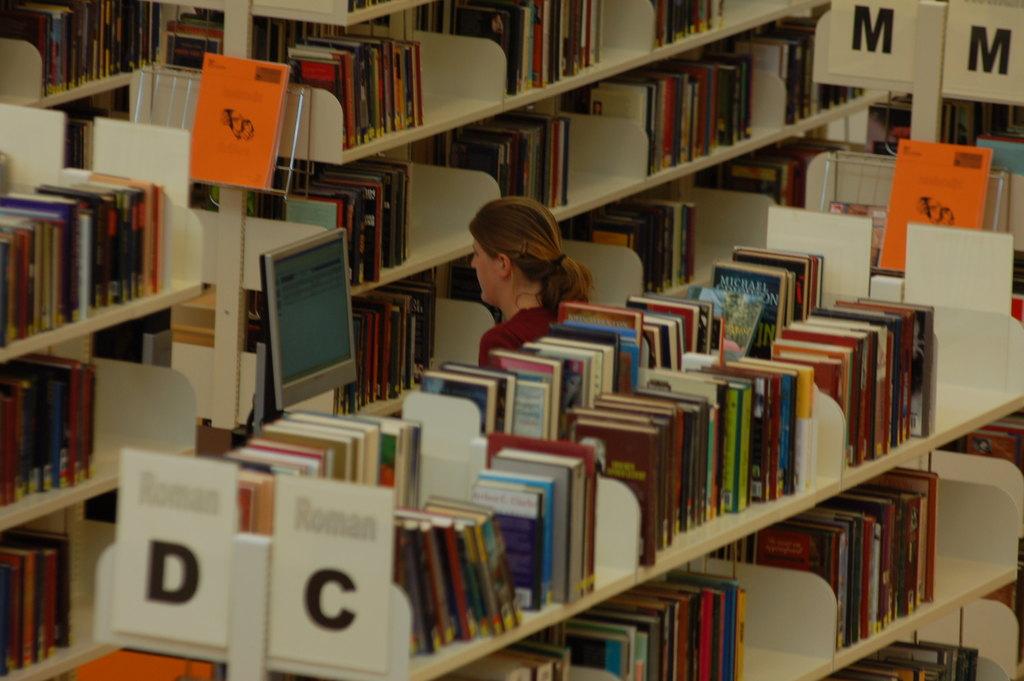What is written above the letters d and c?
Provide a succinct answer. Roman. 